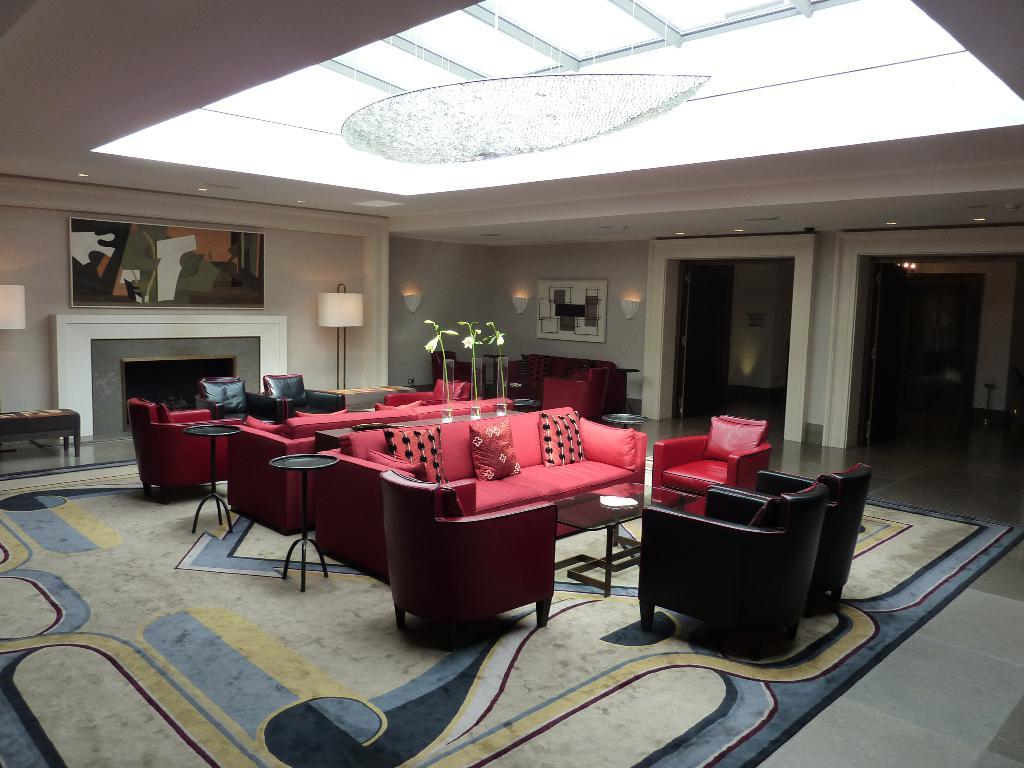How many sofa sets are in the image? There are two sofa sets in the image. What other types of furniture can be seen in the image? There are chairs and tables in the image. What decorative items are present in the image? There are flower vases and photo frames in the image. What type of feature is present in the room? There is a fireplace in the image. What lighting fixtures are visible in the image? There are lamps in the image. What part of the room is not visible in the image? The floor is not visible in the image. Can you tell me how many robins are perched on the lamps in the image? There are no robins present in the image; it features furniture, decorative items, and a fireplace in a room. 